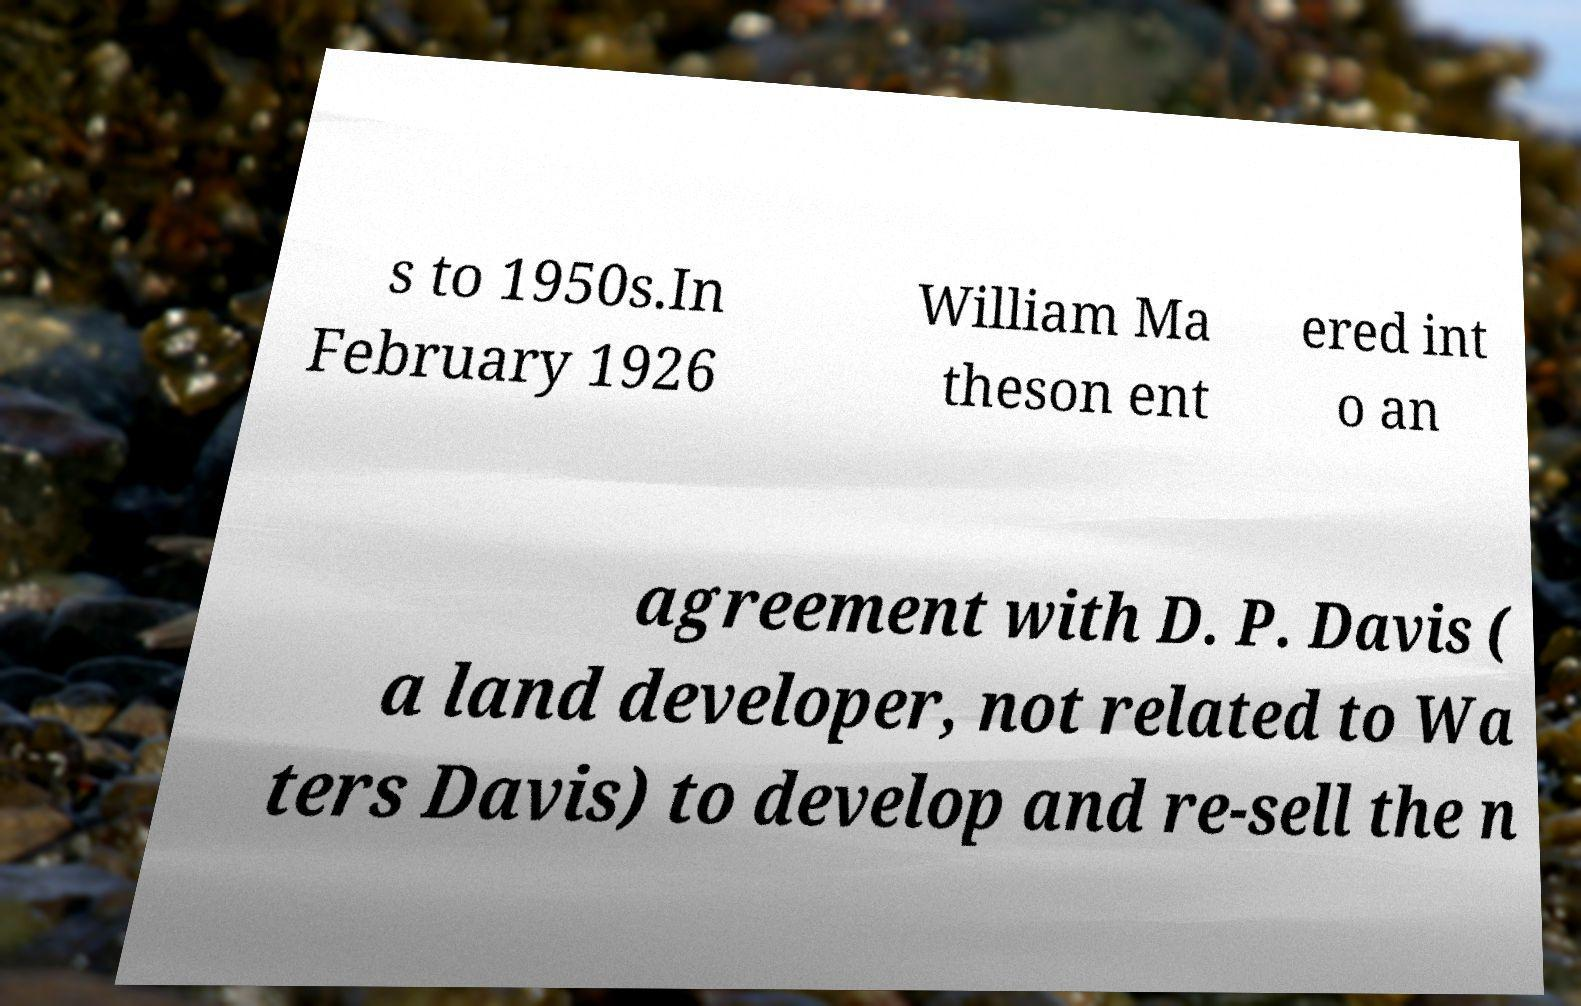Can you read and provide the text displayed in the image?This photo seems to have some interesting text. Can you extract and type it out for me? s to 1950s.In February 1926 William Ma theson ent ered int o an agreement with D. P. Davis ( a land developer, not related to Wa ters Davis) to develop and re-sell the n 